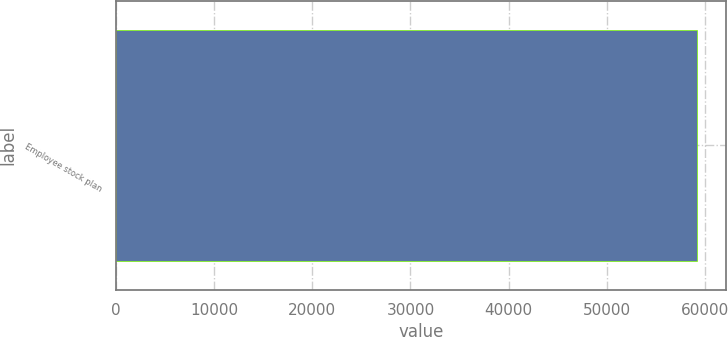<chart> <loc_0><loc_0><loc_500><loc_500><bar_chart><fcel>Employee stock plan<nl><fcel>59164<nl></chart> 